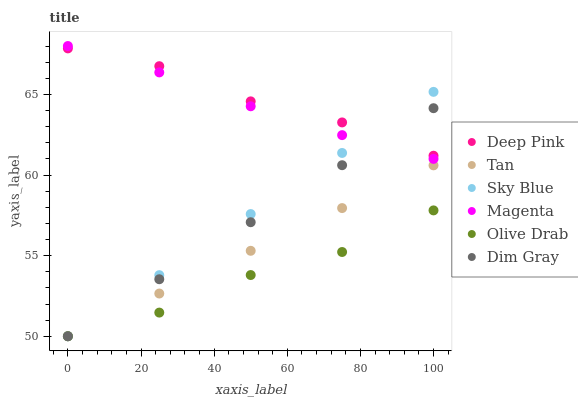Does Olive Drab have the minimum area under the curve?
Answer yes or no. Yes. Does Deep Pink have the maximum area under the curve?
Answer yes or no. Yes. Does Sky Blue have the minimum area under the curve?
Answer yes or no. No. Does Sky Blue have the maximum area under the curve?
Answer yes or no. No. Is Dim Gray the smoothest?
Answer yes or no. Yes. Is Olive Drab the roughest?
Answer yes or no. Yes. Is Deep Pink the smoothest?
Answer yes or no. No. Is Deep Pink the roughest?
Answer yes or no. No. Does Dim Gray have the lowest value?
Answer yes or no. Yes. Does Deep Pink have the lowest value?
Answer yes or no. No. Does Magenta have the highest value?
Answer yes or no. Yes. Does Deep Pink have the highest value?
Answer yes or no. No. Is Olive Drab less than Magenta?
Answer yes or no. Yes. Is Magenta greater than Olive Drab?
Answer yes or no. Yes. Does Sky Blue intersect Magenta?
Answer yes or no. Yes. Is Sky Blue less than Magenta?
Answer yes or no. No. Is Sky Blue greater than Magenta?
Answer yes or no. No. Does Olive Drab intersect Magenta?
Answer yes or no. No. 